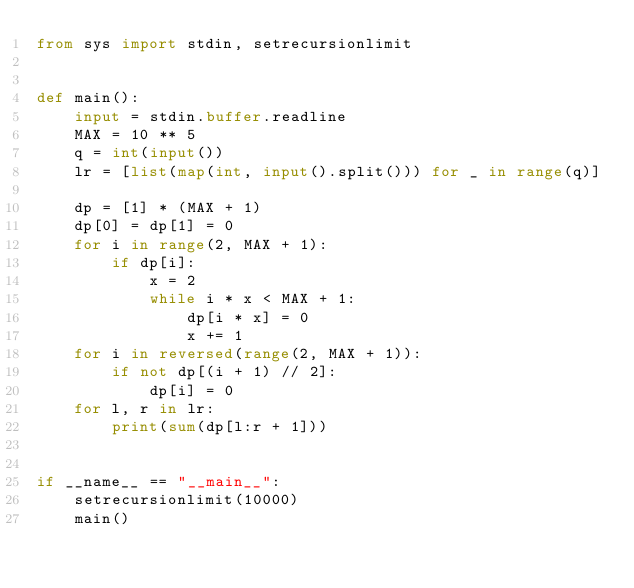<code> <loc_0><loc_0><loc_500><loc_500><_Python_>from sys import stdin, setrecursionlimit


def main():
    input = stdin.buffer.readline
    MAX = 10 ** 5
    q = int(input())
    lr = [list(map(int, input().split())) for _ in range(q)]

    dp = [1] * (MAX + 1)
    dp[0] = dp[1] = 0
    for i in range(2, MAX + 1):
        if dp[i]:
            x = 2
            while i * x < MAX + 1:
                dp[i * x] = 0
                x += 1
    for i in reversed(range(2, MAX + 1)):
        if not dp[(i + 1) // 2]:
            dp[i] = 0
    for l, r in lr:
        print(sum(dp[l:r + 1]))


if __name__ == "__main__":
    setrecursionlimit(10000)
    main()
</code> 